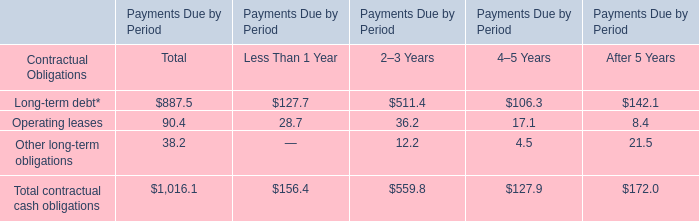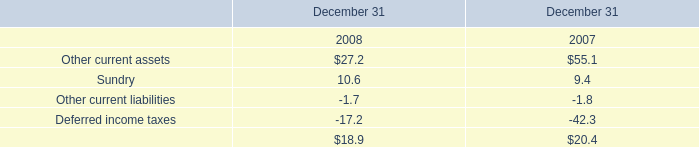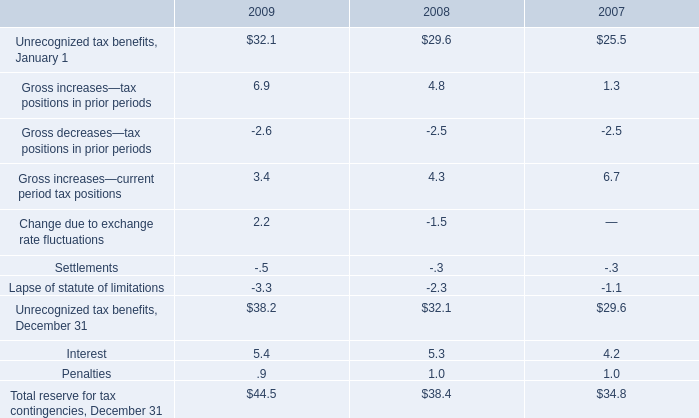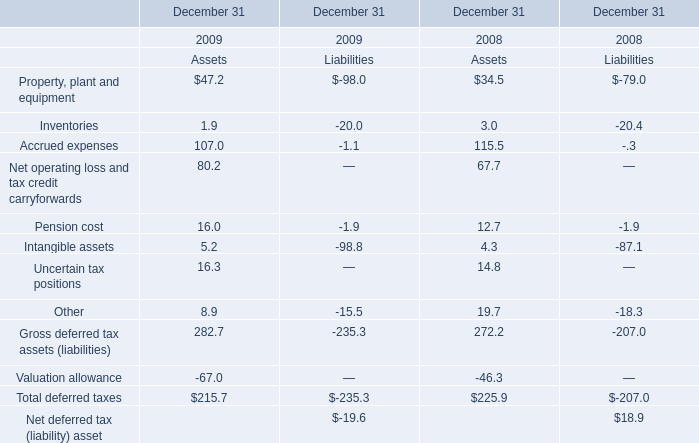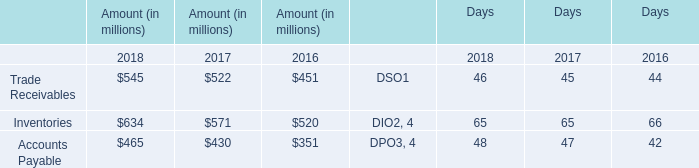When is Gross increases—tax positions in prior periods the largest? 
Answer: 2009. 